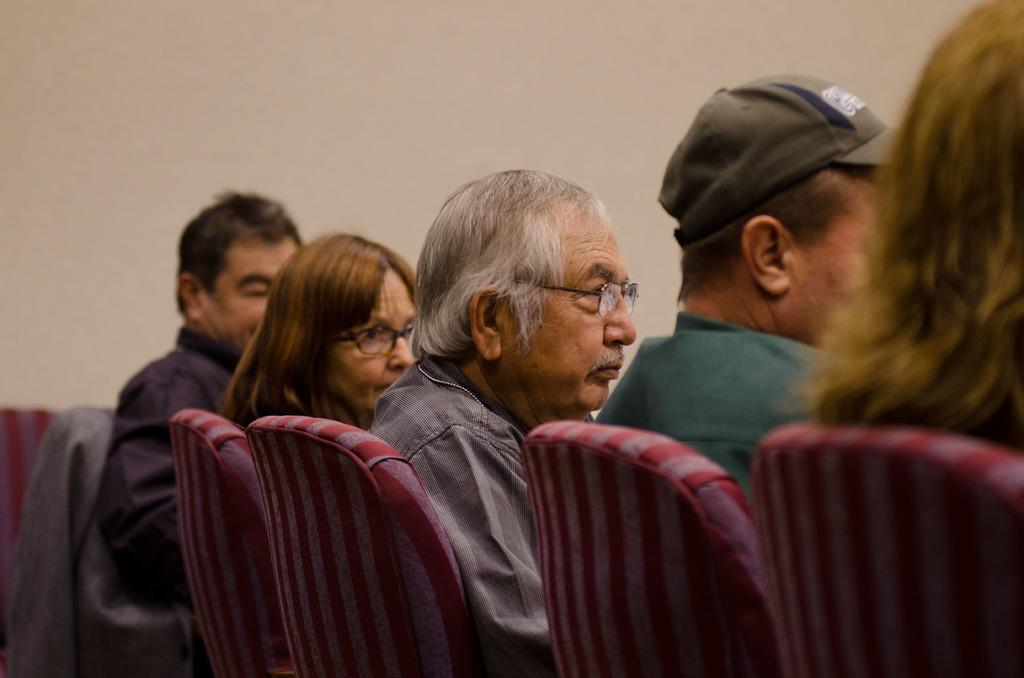What is the old man doing in the image? The old man is sitting on a chair in the image. What is the old man wearing? The old man is wearing a shirt and spectacles. Who is sitting beside the old man? There is a woman sitting beside the old man. How many other persons are sitting in the image? There are other persons sitting in the image, but the exact number is not specified. What can be seen in the background of the image? There is a wall visible in the image. What type of mint is being used by the organization in the image? There is no mention of mint or an organization in the image; it features an old man sitting on a chair with a woman and other persons nearby. 